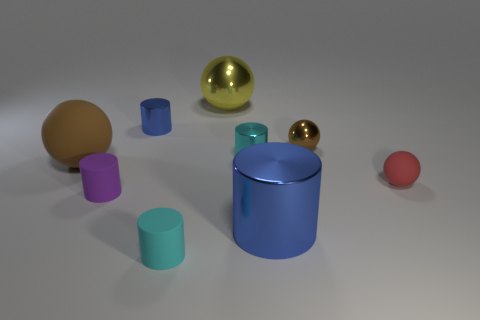Subtract all purple cylinders. How many cylinders are left? 4 Subtract all small purple cylinders. How many cylinders are left? 4 Subtract all red cylinders. Subtract all green blocks. How many cylinders are left? 5 Add 1 yellow things. How many objects exist? 10 Subtract all cylinders. How many objects are left? 4 Subtract 0 gray balls. How many objects are left? 9 Subtract all large purple metallic spheres. Subtract all big rubber balls. How many objects are left? 8 Add 4 tiny red things. How many tiny red things are left? 5 Add 4 small purple shiny things. How many small purple shiny things exist? 4 